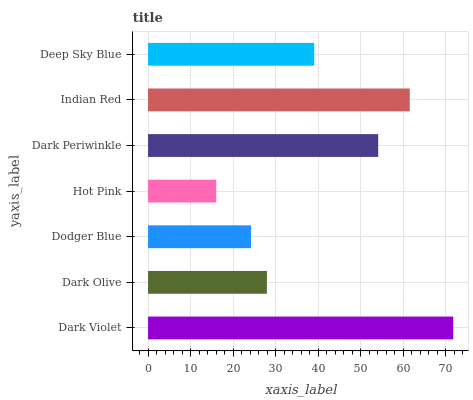Is Hot Pink the minimum?
Answer yes or no. Yes. Is Dark Violet the maximum?
Answer yes or no. Yes. Is Dark Olive the minimum?
Answer yes or no. No. Is Dark Olive the maximum?
Answer yes or no. No. Is Dark Violet greater than Dark Olive?
Answer yes or no. Yes. Is Dark Olive less than Dark Violet?
Answer yes or no. Yes. Is Dark Olive greater than Dark Violet?
Answer yes or no. No. Is Dark Violet less than Dark Olive?
Answer yes or no. No. Is Deep Sky Blue the high median?
Answer yes or no. Yes. Is Deep Sky Blue the low median?
Answer yes or no. Yes. Is Hot Pink the high median?
Answer yes or no. No. Is Dodger Blue the low median?
Answer yes or no. No. 